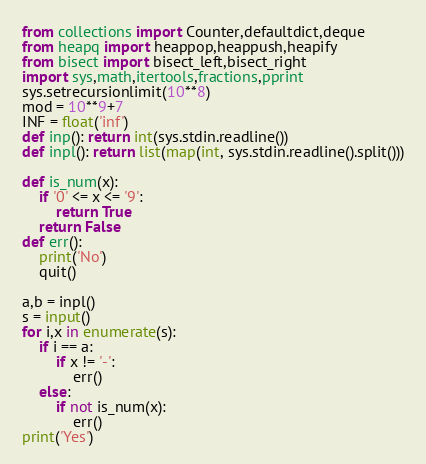Convert code to text. <code><loc_0><loc_0><loc_500><loc_500><_Python_>from collections import Counter,defaultdict,deque
from heapq import heappop,heappush,heapify
from bisect import bisect_left,bisect_right 
import sys,math,itertools,fractions,pprint
sys.setrecursionlimit(10**8)
mod = 10**9+7
INF = float('inf')
def inp(): return int(sys.stdin.readline())
def inpl(): return list(map(int, sys.stdin.readline().split()))

def is_num(x):
    if '0' <= x <= '9':
        return True
    return False
def err():
    print('No')
    quit()

a,b = inpl()
s = input()
for i,x in enumerate(s):
    if i == a:
        if x != '-':
            err()
    else:
        if not is_num(x):
            err()
print('Yes')</code> 